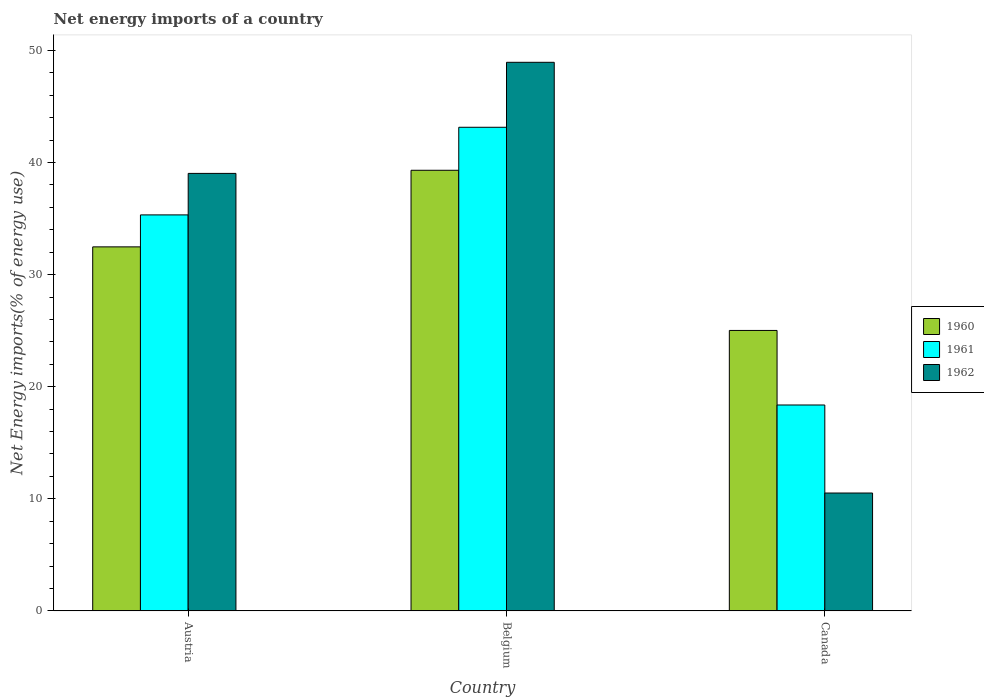Are the number of bars on each tick of the X-axis equal?
Your answer should be compact. Yes. What is the label of the 2nd group of bars from the left?
Your answer should be compact. Belgium. What is the net energy imports in 1961 in Austria?
Your answer should be very brief. 35.33. Across all countries, what is the maximum net energy imports in 1960?
Offer a very short reply. 39.31. Across all countries, what is the minimum net energy imports in 1960?
Ensure brevity in your answer.  25.02. What is the total net energy imports in 1961 in the graph?
Ensure brevity in your answer.  96.84. What is the difference between the net energy imports in 1961 in Austria and that in Belgium?
Your answer should be compact. -7.82. What is the difference between the net energy imports in 1962 in Canada and the net energy imports in 1961 in Austria?
Make the answer very short. -24.81. What is the average net energy imports in 1961 per country?
Provide a short and direct response. 32.28. What is the difference between the net energy imports of/in 1960 and net energy imports of/in 1961 in Austria?
Give a very brief answer. -2.85. What is the ratio of the net energy imports in 1960 in Austria to that in Canada?
Give a very brief answer. 1.3. Is the net energy imports in 1960 in Austria less than that in Canada?
Provide a succinct answer. No. What is the difference between the highest and the second highest net energy imports in 1960?
Make the answer very short. 7.46. What is the difference between the highest and the lowest net energy imports in 1960?
Your answer should be very brief. 14.29. In how many countries, is the net energy imports in 1961 greater than the average net energy imports in 1961 taken over all countries?
Give a very brief answer. 2. Is the sum of the net energy imports in 1962 in Austria and Belgium greater than the maximum net energy imports in 1961 across all countries?
Your answer should be compact. Yes. What does the 1st bar from the left in Austria represents?
Keep it short and to the point. 1960. What does the 1st bar from the right in Belgium represents?
Your response must be concise. 1962. Are all the bars in the graph horizontal?
Keep it short and to the point. No. What is the difference between two consecutive major ticks on the Y-axis?
Provide a short and direct response. 10. Does the graph contain any zero values?
Give a very brief answer. No. Does the graph contain grids?
Make the answer very short. No. Where does the legend appear in the graph?
Give a very brief answer. Center right. How many legend labels are there?
Provide a succinct answer. 3. What is the title of the graph?
Give a very brief answer. Net energy imports of a country. What is the label or title of the X-axis?
Provide a succinct answer. Country. What is the label or title of the Y-axis?
Provide a short and direct response. Net Energy imports(% of energy use). What is the Net Energy imports(% of energy use) in 1960 in Austria?
Your answer should be compact. 32.48. What is the Net Energy imports(% of energy use) in 1961 in Austria?
Your answer should be compact. 35.33. What is the Net Energy imports(% of energy use) in 1962 in Austria?
Offer a very short reply. 39.03. What is the Net Energy imports(% of energy use) of 1960 in Belgium?
Your answer should be compact. 39.31. What is the Net Energy imports(% of energy use) of 1961 in Belgium?
Your answer should be compact. 43.14. What is the Net Energy imports(% of energy use) of 1962 in Belgium?
Your answer should be compact. 48.94. What is the Net Energy imports(% of energy use) of 1960 in Canada?
Your answer should be compact. 25.02. What is the Net Energy imports(% of energy use) of 1961 in Canada?
Provide a short and direct response. 18.37. What is the Net Energy imports(% of energy use) in 1962 in Canada?
Provide a succinct answer. 10.52. Across all countries, what is the maximum Net Energy imports(% of energy use) of 1960?
Your answer should be compact. 39.31. Across all countries, what is the maximum Net Energy imports(% of energy use) of 1961?
Make the answer very short. 43.14. Across all countries, what is the maximum Net Energy imports(% of energy use) in 1962?
Offer a very short reply. 48.94. Across all countries, what is the minimum Net Energy imports(% of energy use) in 1960?
Your response must be concise. 25.02. Across all countries, what is the minimum Net Energy imports(% of energy use) of 1961?
Provide a short and direct response. 18.37. Across all countries, what is the minimum Net Energy imports(% of energy use) in 1962?
Your answer should be very brief. 10.52. What is the total Net Energy imports(% of energy use) in 1960 in the graph?
Offer a very short reply. 96.8. What is the total Net Energy imports(% of energy use) in 1961 in the graph?
Offer a very short reply. 96.84. What is the total Net Energy imports(% of energy use) in 1962 in the graph?
Ensure brevity in your answer.  98.49. What is the difference between the Net Energy imports(% of energy use) in 1960 in Austria and that in Belgium?
Offer a very short reply. -6.83. What is the difference between the Net Energy imports(% of energy use) in 1961 in Austria and that in Belgium?
Your response must be concise. -7.82. What is the difference between the Net Energy imports(% of energy use) in 1962 in Austria and that in Belgium?
Your answer should be compact. -9.91. What is the difference between the Net Energy imports(% of energy use) of 1960 in Austria and that in Canada?
Ensure brevity in your answer.  7.46. What is the difference between the Net Energy imports(% of energy use) of 1961 in Austria and that in Canada?
Provide a short and direct response. 16.96. What is the difference between the Net Energy imports(% of energy use) in 1962 in Austria and that in Canada?
Offer a terse response. 28.52. What is the difference between the Net Energy imports(% of energy use) of 1960 in Belgium and that in Canada?
Your response must be concise. 14.29. What is the difference between the Net Energy imports(% of energy use) of 1961 in Belgium and that in Canada?
Offer a very short reply. 24.78. What is the difference between the Net Energy imports(% of energy use) of 1962 in Belgium and that in Canada?
Offer a very short reply. 38.43. What is the difference between the Net Energy imports(% of energy use) of 1960 in Austria and the Net Energy imports(% of energy use) of 1961 in Belgium?
Provide a succinct answer. -10.67. What is the difference between the Net Energy imports(% of energy use) in 1960 in Austria and the Net Energy imports(% of energy use) in 1962 in Belgium?
Provide a short and direct response. -16.46. What is the difference between the Net Energy imports(% of energy use) in 1961 in Austria and the Net Energy imports(% of energy use) in 1962 in Belgium?
Your answer should be very brief. -13.61. What is the difference between the Net Energy imports(% of energy use) of 1960 in Austria and the Net Energy imports(% of energy use) of 1961 in Canada?
Your response must be concise. 14.11. What is the difference between the Net Energy imports(% of energy use) in 1960 in Austria and the Net Energy imports(% of energy use) in 1962 in Canada?
Keep it short and to the point. 21.96. What is the difference between the Net Energy imports(% of energy use) of 1961 in Austria and the Net Energy imports(% of energy use) of 1962 in Canada?
Offer a terse response. 24.81. What is the difference between the Net Energy imports(% of energy use) of 1960 in Belgium and the Net Energy imports(% of energy use) of 1961 in Canada?
Offer a terse response. 20.94. What is the difference between the Net Energy imports(% of energy use) of 1960 in Belgium and the Net Energy imports(% of energy use) of 1962 in Canada?
Provide a short and direct response. 28.79. What is the difference between the Net Energy imports(% of energy use) in 1961 in Belgium and the Net Energy imports(% of energy use) in 1962 in Canada?
Ensure brevity in your answer.  32.63. What is the average Net Energy imports(% of energy use) in 1960 per country?
Give a very brief answer. 32.27. What is the average Net Energy imports(% of energy use) of 1961 per country?
Keep it short and to the point. 32.28. What is the average Net Energy imports(% of energy use) of 1962 per country?
Offer a very short reply. 32.83. What is the difference between the Net Energy imports(% of energy use) in 1960 and Net Energy imports(% of energy use) in 1961 in Austria?
Provide a short and direct response. -2.85. What is the difference between the Net Energy imports(% of energy use) in 1960 and Net Energy imports(% of energy use) in 1962 in Austria?
Ensure brevity in your answer.  -6.55. What is the difference between the Net Energy imports(% of energy use) of 1961 and Net Energy imports(% of energy use) of 1962 in Austria?
Ensure brevity in your answer.  -3.7. What is the difference between the Net Energy imports(% of energy use) in 1960 and Net Energy imports(% of energy use) in 1961 in Belgium?
Your answer should be very brief. -3.83. What is the difference between the Net Energy imports(% of energy use) of 1960 and Net Energy imports(% of energy use) of 1962 in Belgium?
Offer a terse response. -9.63. What is the difference between the Net Energy imports(% of energy use) of 1961 and Net Energy imports(% of energy use) of 1962 in Belgium?
Give a very brief answer. -5.8. What is the difference between the Net Energy imports(% of energy use) in 1960 and Net Energy imports(% of energy use) in 1961 in Canada?
Offer a very short reply. 6.65. What is the difference between the Net Energy imports(% of energy use) in 1960 and Net Energy imports(% of energy use) in 1962 in Canada?
Make the answer very short. 14.5. What is the difference between the Net Energy imports(% of energy use) of 1961 and Net Energy imports(% of energy use) of 1962 in Canada?
Offer a terse response. 7.85. What is the ratio of the Net Energy imports(% of energy use) of 1960 in Austria to that in Belgium?
Ensure brevity in your answer.  0.83. What is the ratio of the Net Energy imports(% of energy use) of 1961 in Austria to that in Belgium?
Make the answer very short. 0.82. What is the ratio of the Net Energy imports(% of energy use) in 1962 in Austria to that in Belgium?
Keep it short and to the point. 0.8. What is the ratio of the Net Energy imports(% of energy use) of 1960 in Austria to that in Canada?
Your answer should be compact. 1.3. What is the ratio of the Net Energy imports(% of energy use) in 1961 in Austria to that in Canada?
Give a very brief answer. 1.92. What is the ratio of the Net Energy imports(% of energy use) of 1962 in Austria to that in Canada?
Your answer should be very brief. 3.71. What is the ratio of the Net Energy imports(% of energy use) of 1960 in Belgium to that in Canada?
Ensure brevity in your answer.  1.57. What is the ratio of the Net Energy imports(% of energy use) in 1961 in Belgium to that in Canada?
Keep it short and to the point. 2.35. What is the ratio of the Net Energy imports(% of energy use) of 1962 in Belgium to that in Canada?
Your answer should be very brief. 4.65. What is the difference between the highest and the second highest Net Energy imports(% of energy use) of 1960?
Ensure brevity in your answer.  6.83. What is the difference between the highest and the second highest Net Energy imports(% of energy use) in 1961?
Provide a short and direct response. 7.82. What is the difference between the highest and the second highest Net Energy imports(% of energy use) in 1962?
Offer a terse response. 9.91. What is the difference between the highest and the lowest Net Energy imports(% of energy use) in 1960?
Offer a very short reply. 14.29. What is the difference between the highest and the lowest Net Energy imports(% of energy use) in 1961?
Keep it short and to the point. 24.78. What is the difference between the highest and the lowest Net Energy imports(% of energy use) in 1962?
Ensure brevity in your answer.  38.43. 